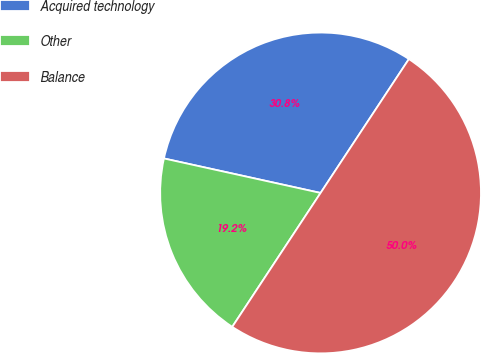Convert chart. <chart><loc_0><loc_0><loc_500><loc_500><pie_chart><fcel>Acquired technology<fcel>Other<fcel>Balance<nl><fcel>30.83%<fcel>19.17%<fcel>50.0%<nl></chart> 